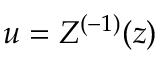Convert formula to latex. <formula><loc_0><loc_0><loc_500><loc_500>u = Z ^ { ( - 1 ) } ( z )</formula> 